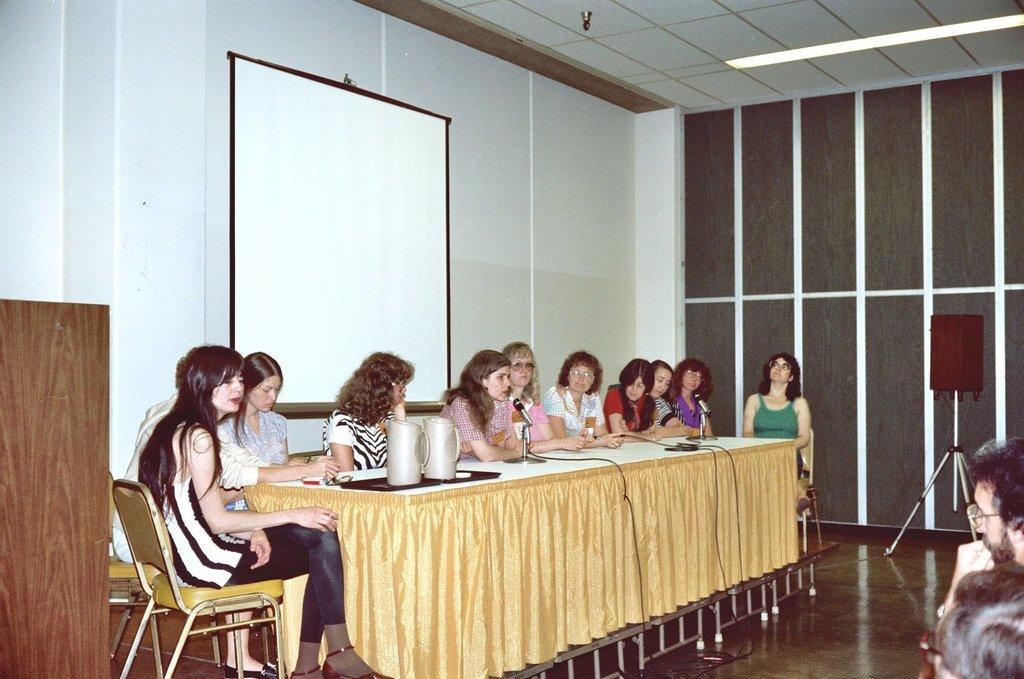How would you summarize this image in a sentence or two? In this image I can see few women are sitting on chairs. Here on this table I can see few jugs and few mics. I can also see a projector's screen and a speaker. 